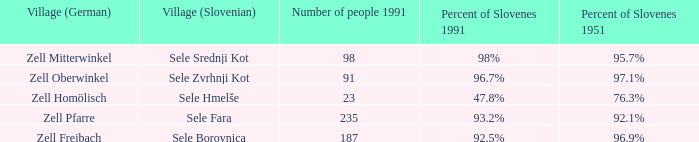Provide me with the name of all the village (German) that are part of the village (Slovenian) with sele borovnica. Zell Freibach. 